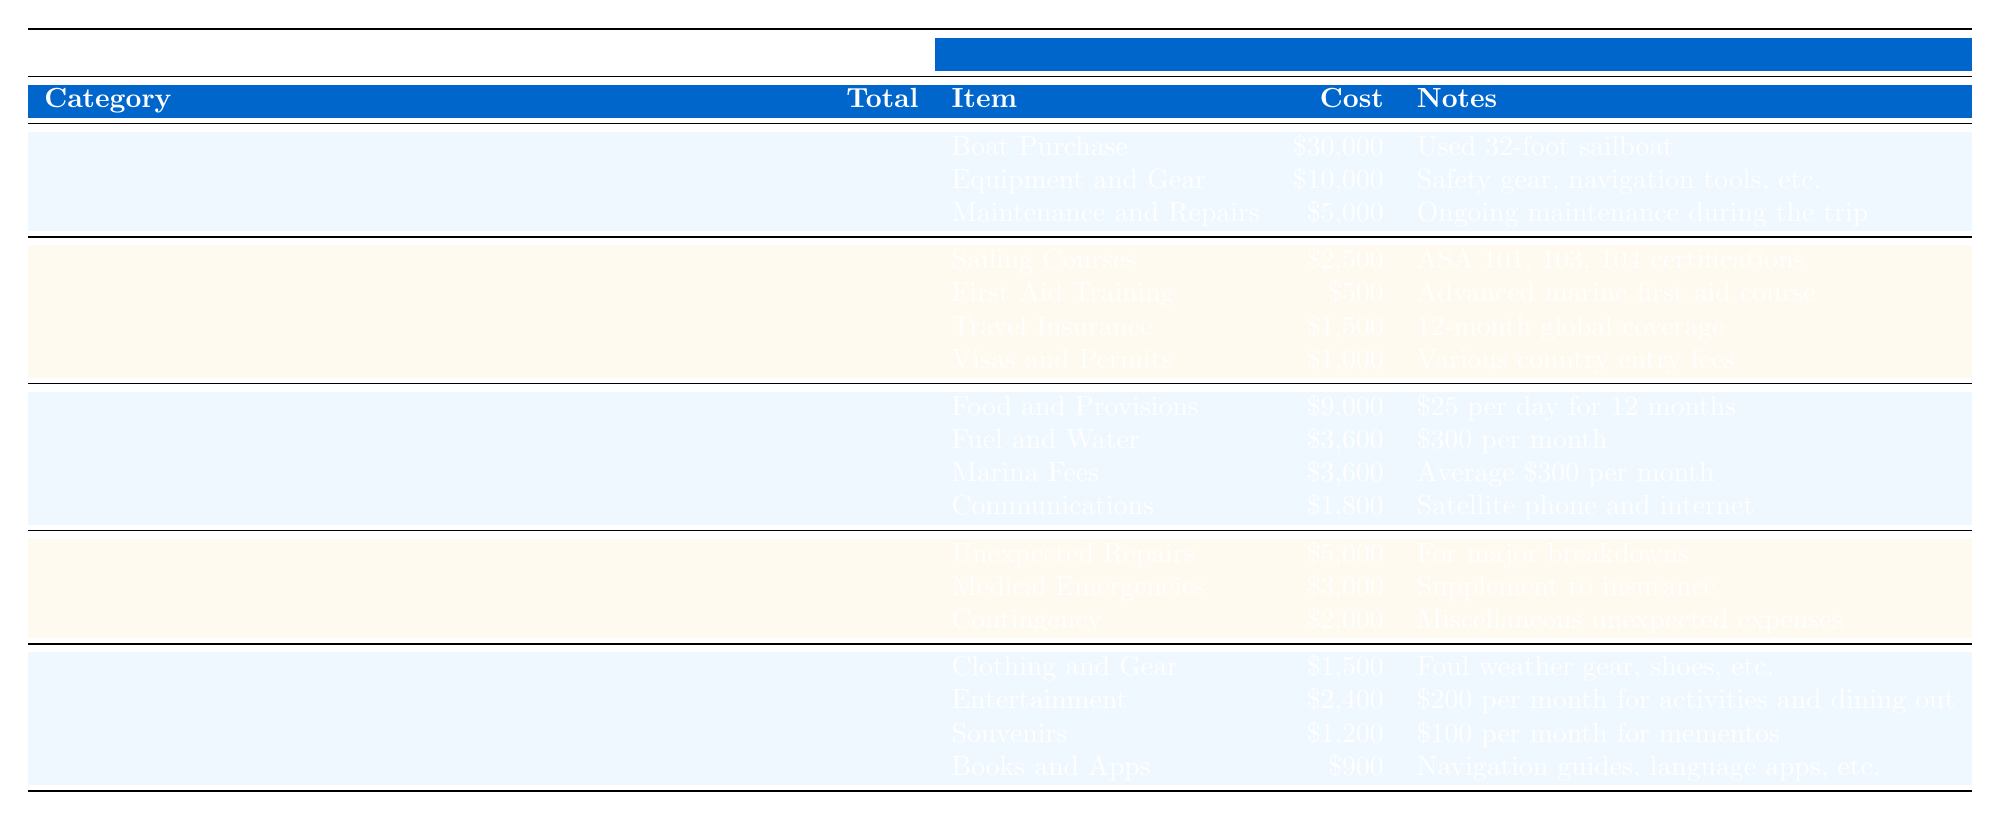What is the total cost of Vessel Expenses? According to the table, the total cost listed under Vessel Expenses is $45,000.
Answer: $45,000 How much was spent on Sailing Courses? The table specifies that $2,500 was allocated for Sailing Courses under the Trip Preparations category.
Answer: $2,500 What is the total budget for Daily Living Expenses? The table shows that the total for Daily Living Expenses is $18,000.
Answer: $18,000 Is the cost for unexpected repairs under the Emergency Fund category greater than the cost for Medical Emergencies? The table indicates that unexpected repairs cost $5,000, while medical emergencies cost $3,000. Since $5,000 is greater than $3,000, the statement is true.
Answer: Yes What is the combined total of costs for Food and Provisions and Communications? From the table, Food and Provisions cost $9,000, and Communications cost $1,800. Adding them together gives $9,000 + $1,800 = $10,800.
Answer: $10,800 What is the percentage of the total budget allocated for Personal Expenses? The overall budget totals $100,500 (sum of all category totals: $45,000 + $5,500 + $18,000 + $10,000 + $6,000). Personal Expenses total $6,000. Calculating the percentage gives ($6,000 / $100,500) * 100 = approximately 5.96%.
Answer: 5.96% Which category has the highest total expenditure, and how much is it? The table reveals that Vessel Expenses totals $45,000, which is higher than any other category. Therefore, Vessel Expenses has the highest total expenditure of $45,000.
Answer: Vessel Expenses, $45,000 What is the total amount allocated for training and insurance under Trip Preparations? The table lists Sailing Courses ($2,500), First Aid Training ($500), and Travel Insurance ($1,500) under Trip Preparations. Summing these values gives $2,500 + $500 + $1,500 = $4,500.
Answer: $4,500 How much more is spent on Entertainment compared to Souvenirs in Personal Expenses? The cost for Entertainment is $2,400, and for Souvenirs, it is $1,200. The difference is $2,400 - $1,200 = $1,200, meaning $1,200 more is spent on Entertainment.
Answer: $1,200 If you budget $300 for Fuel and Water per month, how does this compare to the total cost listed in the table? According to the table, the total for Fuel and Water is $3,600. If you budget $300 per month over 12 months (12 * $300 = $3,600), it matches the total listed in the table.
Answer: They are equal 